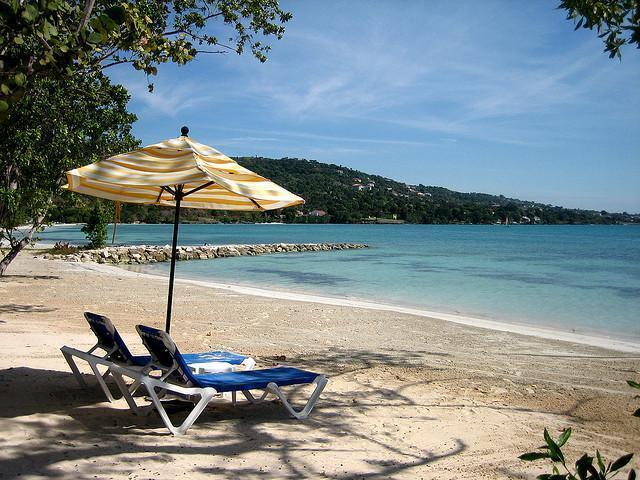How many chairs are there?
Give a very brief answer. 2. 